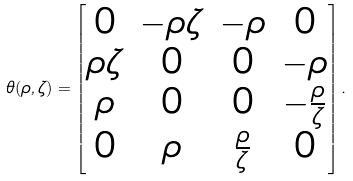<formula> <loc_0><loc_0><loc_500><loc_500>\theta ( \rho , \zeta ) = \begin{bmatrix} 0 & - \rho \zeta & - \rho & 0 \\ \rho \zeta & 0 & 0 & - \rho \\ \rho & 0 & 0 & - \frac { \rho } { \zeta } \\ 0 & \rho & \frac { \rho } { \zeta } & 0 \end{bmatrix} .</formula> 